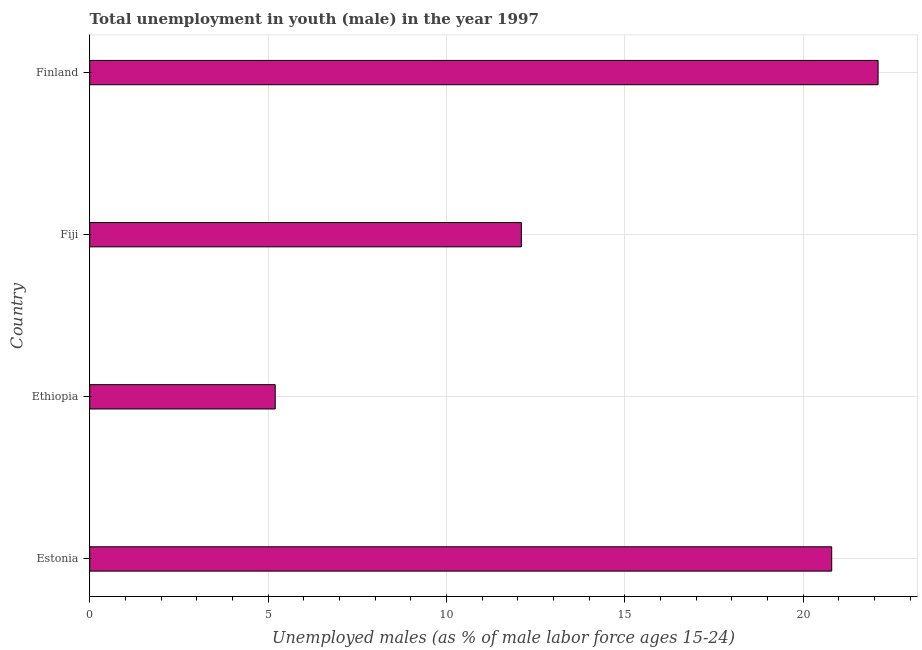Does the graph contain any zero values?
Provide a succinct answer. No. What is the title of the graph?
Your answer should be compact. Total unemployment in youth (male) in the year 1997. What is the label or title of the X-axis?
Your answer should be very brief. Unemployed males (as % of male labor force ages 15-24). What is the label or title of the Y-axis?
Make the answer very short. Country. What is the unemployed male youth population in Finland?
Your answer should be very brief. 22.1. Across all countries, what is the maximum unemployed male youth population?
Provide a short and direct response. 22.1. Across all countries, what is the minimum unemployed male youth population?
Ensure brevity in your answer.  5.2. In which country was the unemployed male youth population minimum?
Ensure brevity in your answer.  Ethiopia. What is the sum of the unemployed male youth population?
Keep it short and to the point. 60.2. What is the difference between the unemployed male youth population in Ethiopia and Finland?
Make the answer very short. -16.9. What is the average unemployed male youth population per country?
Your answer should be very brief. 15.05. What is the median unemployed male youth population?
Ensure brevity in your answer.  16.45. In how many countries, is the unemployed male youth population greater than 16 %?
Provide a succinct answer. 2. What is the ratio of the unemployed male youth population in Ethiopia to that in Fiji?
Offer a terse response. 0.43. What is the difference between the highest and the second highest unemployed male youth population?
Offer a very short reply. 1.3. What is the difference between the highest and the lowest unemployed male youth population?
Give a very brief answer. 16.9. How many bars are there?
Your answer should be very brief. 4. What is the difference between two consecutive major ticks on the X-axis?
Give a very brief answer. 5. What is the Unemployed males (as % of male labor force ages 15-24) in Estonia?
Provide a short and direct response. 20.8. What is the Unemployed males (as % of male labor force ages 15-24) in Ethiopia?
Make the answer very short. 5.2. What is the Unemployed males (as % of male labor force ages 15-24) in Fiji?
Make the answer very short. 12.1. What is the Unemployed males (as % of male labor force ages 15-24) of Finland?
Offer a terse response. 22.1. What is the difference between the Unemployed males (as % of male labor force ages 15-24) in Estonia and Ethiopia?
Provide a succinct answer. 15.6. What is the difference between the Unemployed males (as % of male labor force ages 15-24) in Estonia and Fiji?
Make the answer very short. 8.7. What is the difference between the Unemployed males (as % of male labor force ages 15-24) in Estonia and Finland?
Give a very brief answer. -1.3. What is the difference between the Unemployed males (as % of male labor force ages 15-24) in Ethiopia and Fiji?
Keep it short and to the point. -6.9. What is the difference between the Unemployed males (as % of male labor force ages 15-24) in Ethiopia and Finland?
Provide a succinct answer. -16.9. What is the difference between the Unemployed males (as % of male labor force ages 15-24) in Fiji and Finland?
Provide a succinct answer. -10. What is the ratio of the Unemployed males (as % of male labor force ages 15-24) in Estonia to that in Fiji?
Make the answer very short. 1.72. What is the ratio of the Unemployed males (as % of male labor force ages 15-24) in Estonia to that in Finland?
Offer a terse response. 0.94. What is the ratio of the Unemployed males (as % of male labor force ages 15-24) in Ethiopia to that in Fiji?
Your answer should be compact. 0.43. What is the ratio of the Unemployed males (as % of male labor force ages 15-24) in Ethiopia to that in Finland?
Provide a succinct answer. 0.23. What is the ratio of the Unemployed males (as % of male labor force ages 15-24) in Fiji to that in Finland?
Offer a very short reply. 0.55. 